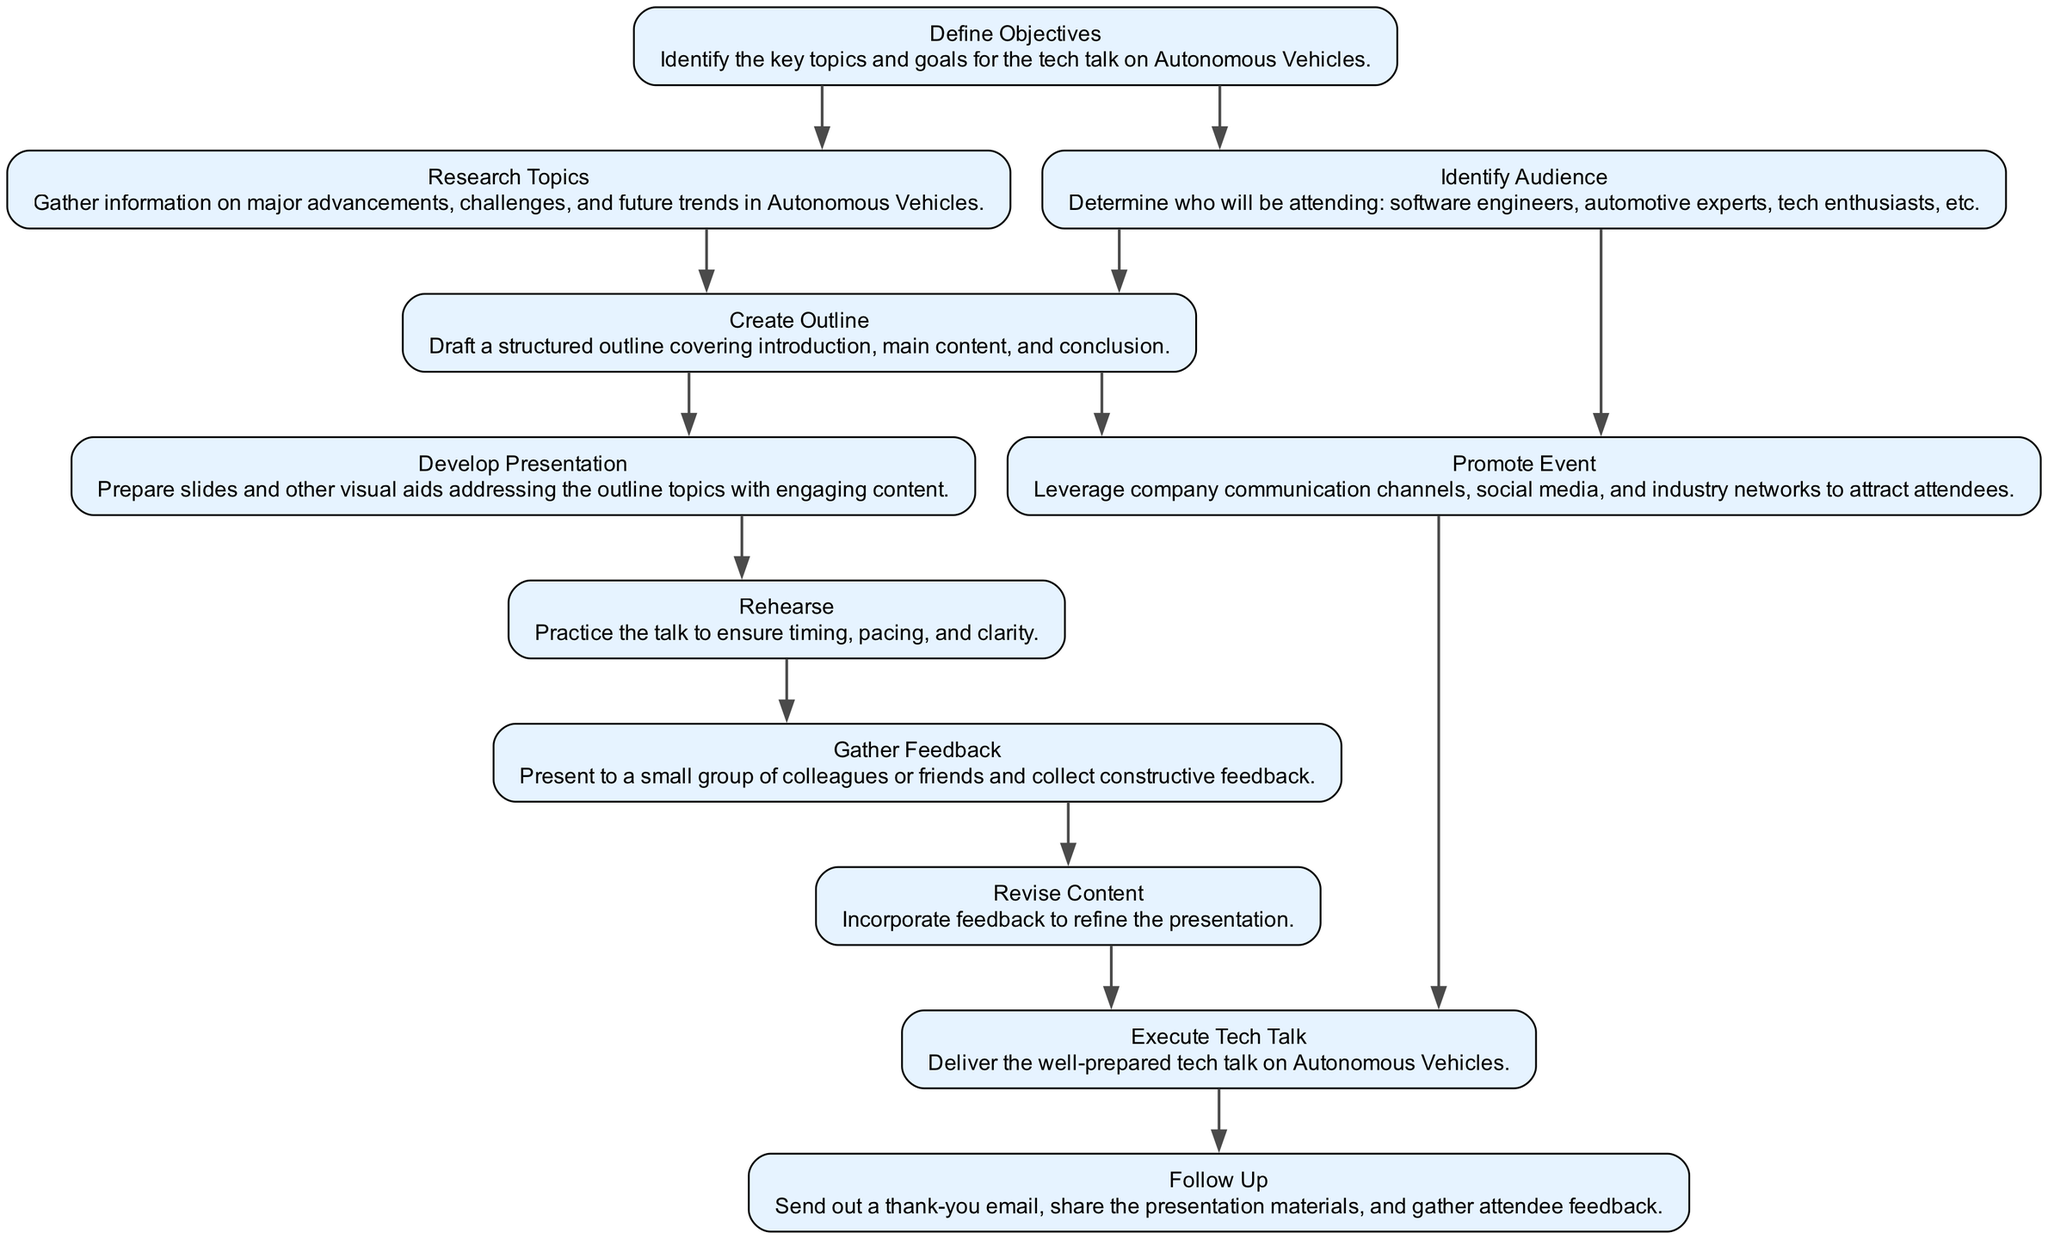What is the first step in planning the tech talk? The first step, according to the diagram, is "Define Objectives," which involves identifying the key topics and goals for the tech talk on Autonomous Vehicles.
Answer: Define Objectives How many steps are indicated in the flowchart? By counting the nodes in the diagram, we find there are 11 steps indicating the overall process for planning and executing the tech talk.
Answer: 11 Which step involves gathering information? The step titled "Research Topics" is specifically focused on gathering information about major advancements, challenges, and future trends in Autonomous Vehicles.
Answer: Research Topics What comes after "Revise Content"? According to the flowchart, after "Revise Content," the next step is "Promote Event," which focuses on leveraging communication channels to attract attendees.
Answer: Promote Event Which steps depend on "Identify Audience"? The steps that depend on "Identify Audience" are "Create Outline" and "Promote Event," indicating that understanding the audience influences both the outline and promotional strategies.
Answer: Create Outline, Promote Event What is the last step to be completed after executing the tech talk? The last step is "Follow Up," which includes sending out thank-you emails, sharing presentation materials, and gathering feedback from attendees.
Answer: Follow Up How many steps contribute to the execution of the tech talk? The execution of the tech talk relies on two steps, which are "Revise Content" and "Promote Event," both of which must be completed prior to execution.
Answer: 2 What is the relationship between "Develop Presentation" and "Create Outline"? "Develop Presentation" is a step that depends on "Create Outline," meaning that developing the presentation content cannot happen until an outline has been established.
Answer: Develop Presentation Which step focuses on timing and pacing? The step called "Rehearse" is primarily concerned with practicing the talk to ensure proper timing, pacing, and clarity before the actual delivery.
Answer: Rehearse 